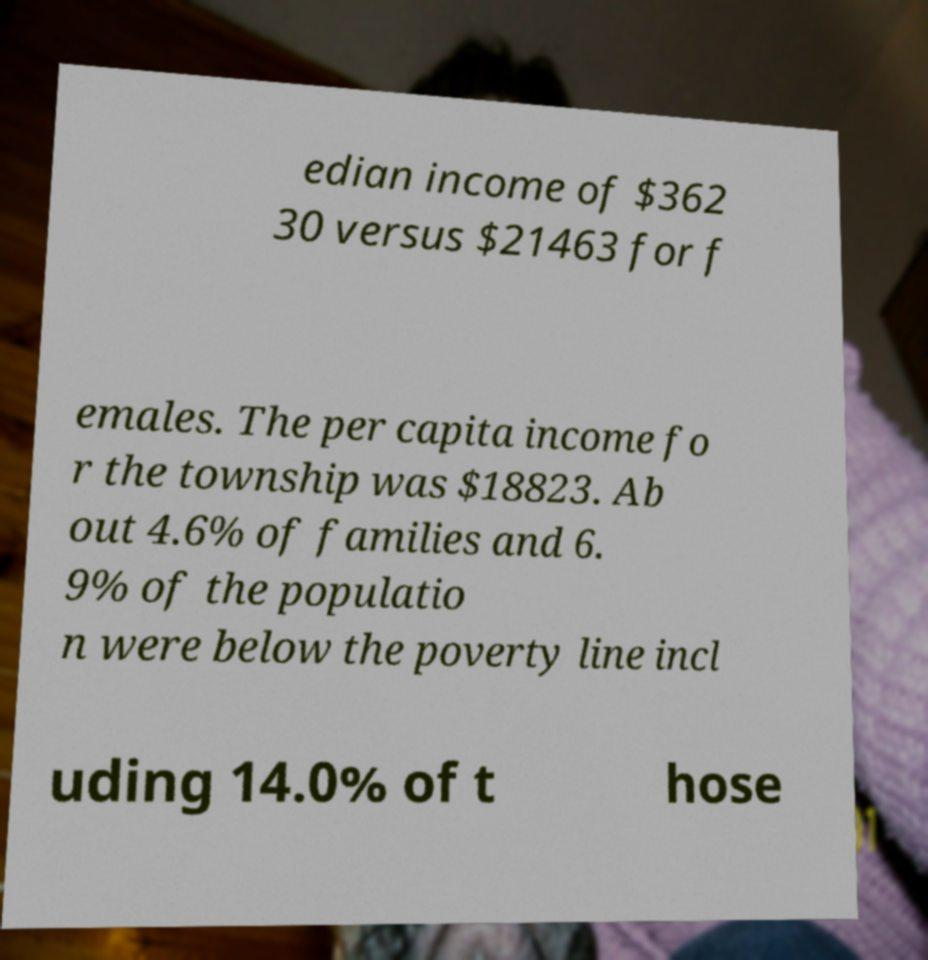Can you read and provide the text displayed in the image?This photo seems to have some interesting text. Can you extract and type it out for me? edian income of $362 30 versus $21463 for f emales. The per capita income fo r the township was $18823. Ab out 4.6% of families and 6. 9% of the populatio n were below the poverty line incl uding 14.0% of t hose 